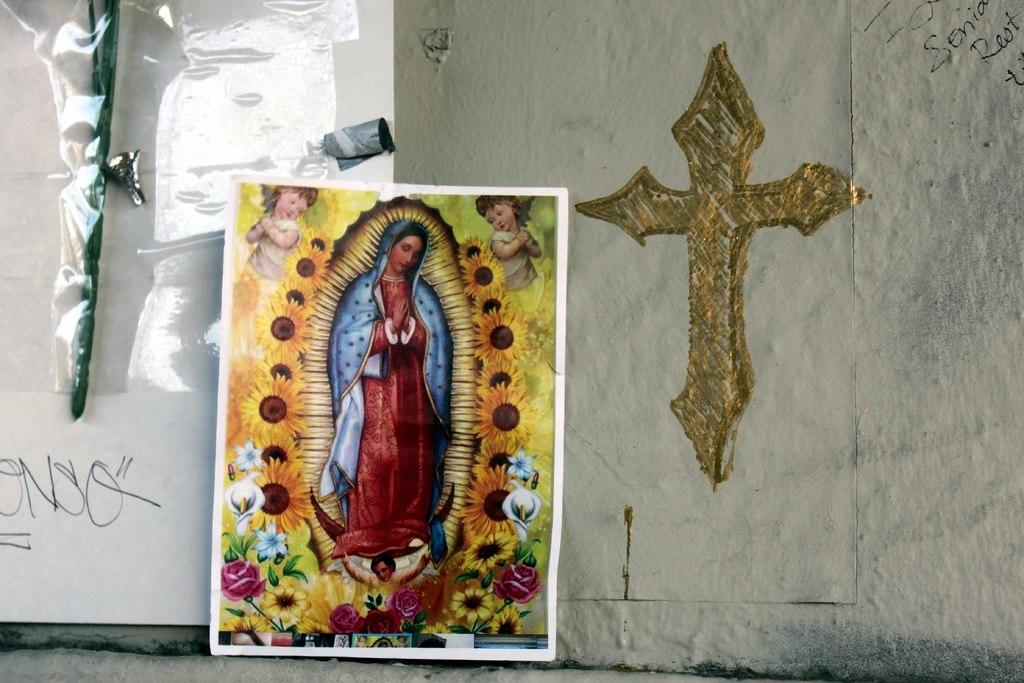Provide a one-sentence caption for the provided image. wall with gold cross on it and religious poster against wall and tagged with letters onso. 